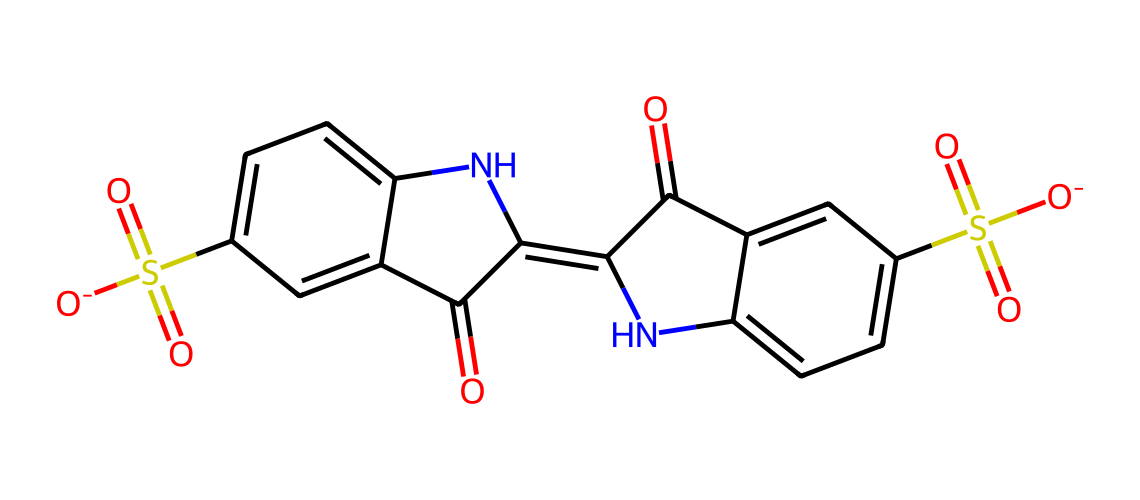what is the chemical name of this compound? By examining the structure and recognizing the SMILES notation, we can identify the compound as indigo carmine, which is a well-known food coloring agent.
Answer: indigo carmine how many nitrogen atoms are present in this molecule? Looking at the SMILES representation, we find that there are 2 nitrogen atoms incorporated in the ring structure of the compound.
Answer: 2 what is the predominant functional group in indigo carmine? In examining the structure, we see the presence of sulfonic acid groups (-SO3H) which are prominent in the molecule; hence, they represent the predominant functional group.
Answer: sulfonic acid does indigo carmine contain any double bonds? The structure, as portrayed through the SMILES, shows multiple instances of double bonds present in the cyclic portions and between the nitrogen and carbon atoms.
Answer: yes how many aromatic rings are in this compound? By analyzing the structure, we can observe that there are 2 distinct aromatic rings present in the indigo carmine molecule due to the presence of alternating double bonds within the rings.
Answer: 2 what type of dye is indigo carmine classified as? The analysis of its chemical structure, notably the presence of azo and indigo structures, classifies indigo carmine as an anthraquinone dye, often used in food coloring.
Answer: anthraquinone what role does the sulfonic acid group play in indigo carmine? The sulfonic acid groups enhance the solubility of indigo carmine in water, making it effective as a food coloring agent while also contributing to its overall polarity.
Answer: solubility 